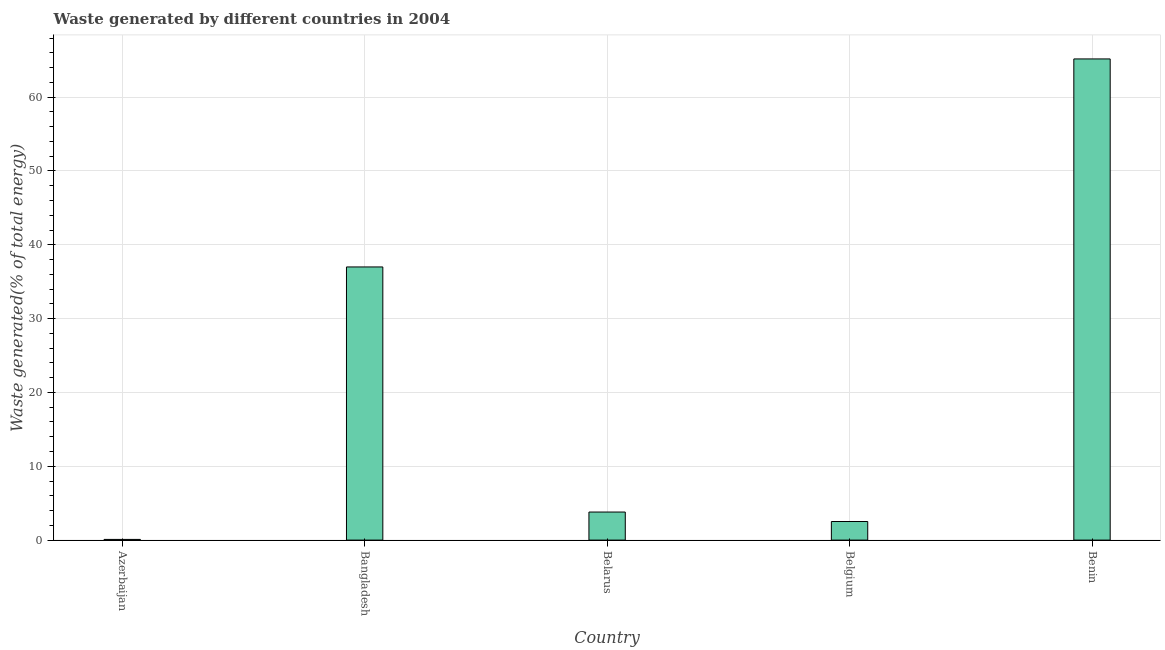Does the graph contain grids?
Give a very brief answer. Yes. What is the title of the graph?
Make the answer very short. Waste generated by different countries in 2004. What is the label or title of the X-axis?
Provide a short and direct response. Country. What is the label or title of the Y-axis?
Your response must be concise. Waste generated(% of total energy). What is the amount of waste generated in Belarus?
Provide a succinct answer. 3.8. Across all countries, what is the maximum amount of waste generated?
Your answer should be compact. 65.18. Across all countries, what is the minimum amount of waste generated?
Your answer should be very brief. 0.09. In which country was the amount of waste generated maximum?
Offer a terse response. Benin. In which country was the amount of waste generated minimum?
Offer a terse response. Azerbaijan. What is the sum of the amount of waste generated?
Offer a very short reply. 108.59. What is the difference between the amount of waste generated in Belarus and Belgium?
Provide a succinct answer. 1.28. What is the average amount of waste generated per country?
Offer a terse response. 21.72. What is the median amount of waste generated?
Your answer should be compact. 3.8. What is the ratio of the amount of waste generated in Azerbaijan to that in Bangladesh?
Give a very brief answer. 0. Is the amount of waste generated in Bangladesh less than that in Belgium?
Your response must be concise. No. Is the difference between the amount of waste generated in Azerbaijan and Benin greater than the difference between any two countries?
Your response must be concise. Yes. What is the difference between the highest and the second highest amount of waste generated?
Give a very brief answer. 28.18. What is the difference between the highest and the lowest amount of waste generated?
Your answer should be compact. 65.08. In how many countries, is the amount of waste generated greater than the average amount of waste generated taken over all countries?
Your answer should be compact. 2. Are all the bars in the graph horizontal?
Ensure brevity in your answer.  No. How many countries are there in the graph?
Ensure brevity in your answer.  5. What is the difference between two consecutive major ticks on the Y-axis?
Your answer should be very brief. 10. What is the Waste generated(% of total energy) in Azerbaijan?
Provide a short and direct response. 0.09. What is the Waste generated(% of total energy) of Bangladesh?
Ensure brevity in your answer.  37. What is the Waste generated(% of total energy) in Belarus?
Provide a short and direct response. 3.8. What is the Waste generated(% of total energy) in Belgium?
Offer a terse response. 2.52. What is the Waste generated(% of total energy) in Benin?
Keep it short and to the point. 65.18. What is the difference between the Waste generated(% of total energy) in Azerbaijan and Bangladesh?
Ensure brevity in your answer.  -36.91. What is the difference between the Waste generated(% of total energy) in Azerbaijan and Belarus?
Offer a terse response. -3.71. What is the difference between the Waste generated(% of total energy) in Azerbaijan and Belgium?
Make the answer very short. -2.42. What is the difference between the Waste generated(% of total energy) in Azerbaijan and Benin?
Your answer should be very brief. -65.08. What is the difference between the Waste generated(% of total energy) in Bangladesh and Belarus?
Your answer should be compact. 33.2. What is the difference between the Waste generated(% of total energy) in Bangladesh and Belgium?
Your response must be concise. 34.48. What is the difference between the Waste generated(% of total energy) in Bangladesh and Benin?
Give a very brief answer. -28.18. What is the difference between the Waste generated(% of total energy) in Belarus and Belgium?
Offer a terse response. 1.28. What is the difference between the Waste generated(% of total energy) in Belarus and Benin?
Your answer should be compact. -61.38. What is the difference between the Waste generated(% of total energy) in Belgium and Benin?
Provide a succinct answer. -62.66. What is the ratio of the Waste generated(% of total energy) in Azerbaijan to that in Bangladesh?
Offer a terse response. 0. What is the ratio of the Waste generated(% of total energy) in Azerbaijan to that in Belarus?
Offer a very short reply. 0.03. What is the ratio of the Waste generated(% of total energy) in Azerbaijan to that in Belgium?
Offer a terse response. 0.04. What is the ratio of the Waste generated(% of total energy) in Bangladesh to that in Belarus?
Make the answer very short. 9.74. What is the ratio of the Waste generated(% of total energy) in Bangladesh to that in Belgium?
Give a very brief answer. 14.7. What is the ratio of the Waste generated(% of total energy) in Bangladesh to that in Benin?
Provide a succinct answer. 0.57. What is the ratio of the Waste generated(% of total energy) in Belarus to that in Belgium?
Offer a very short reply. 1.51. What is the ratio of the Waste generated(% of total energy) in Belarus to that in Benin?
Keep it short and to the point. 0.06. What is the ratio of the Waste generated(% of total energy) in Belgium to that in Benin?
Make the answer very short. 0.04. 